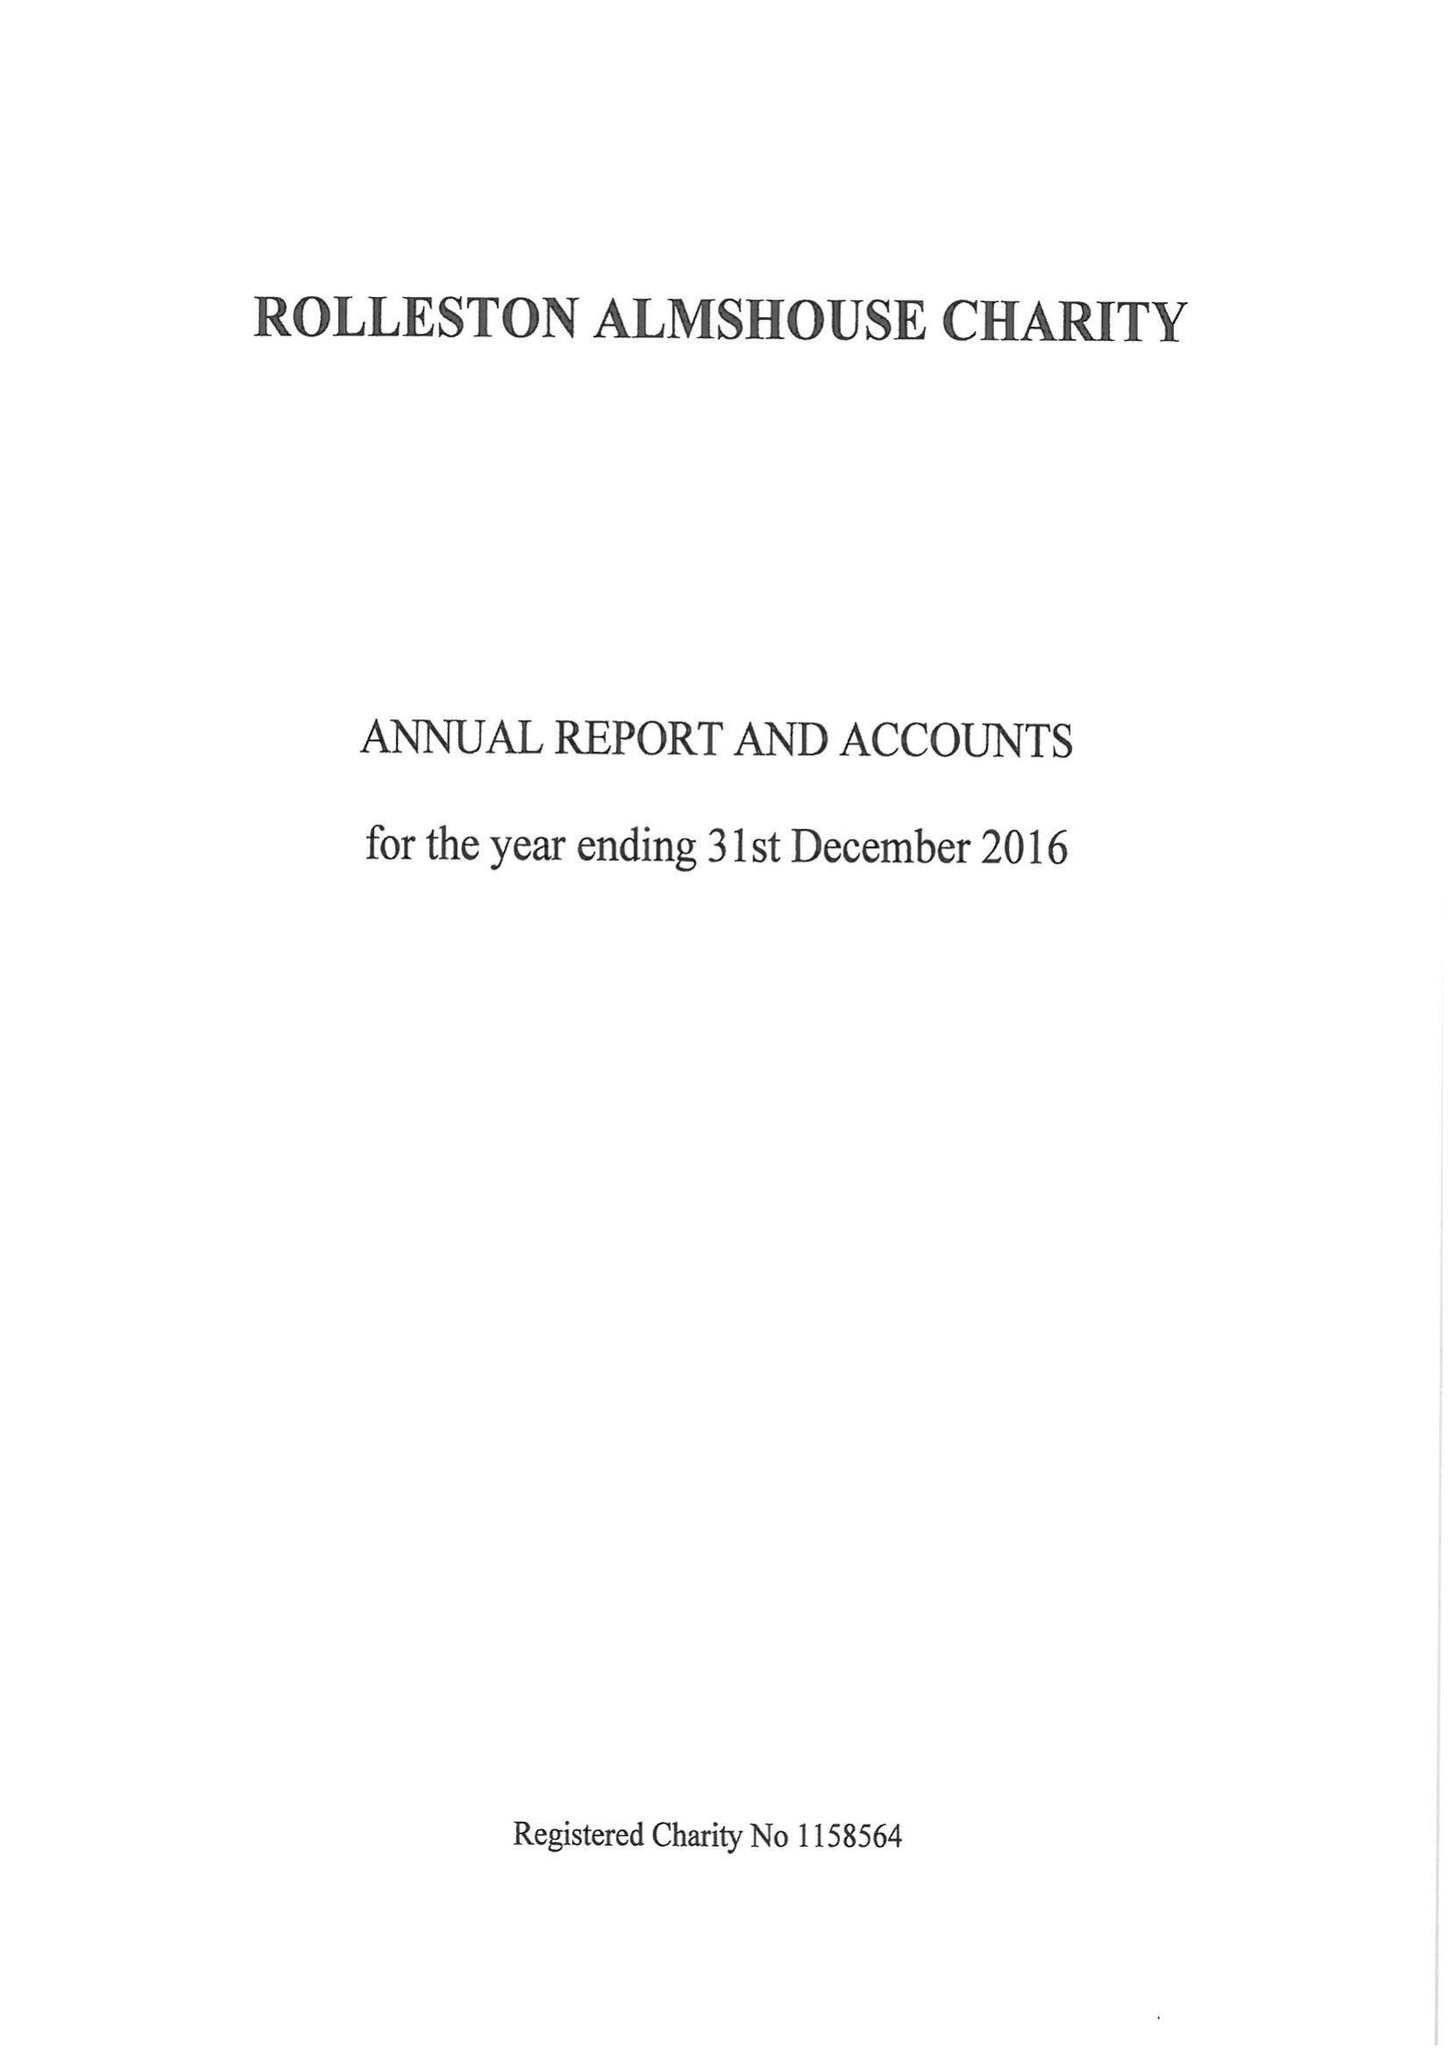What is the value for the address__street_line?
Answer the question using a single word or phrase. 148 HIGH STREET 